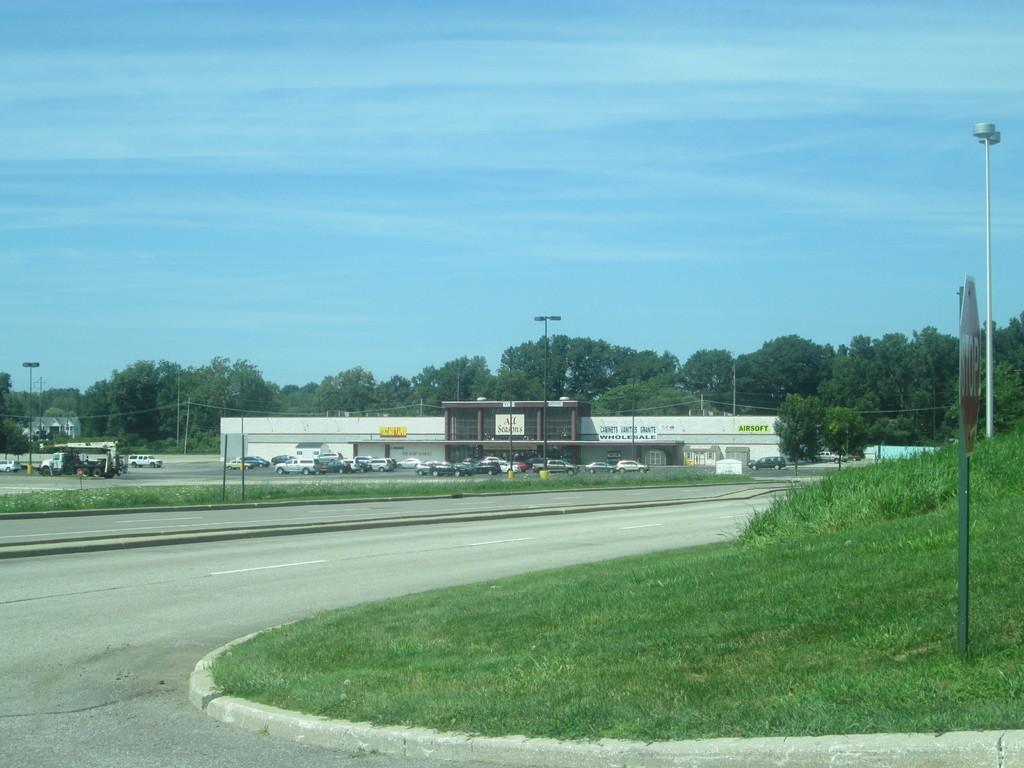Can you describe this image briefly? In this picture I can see some vehicles side of the road near building and side I can see some grass. 